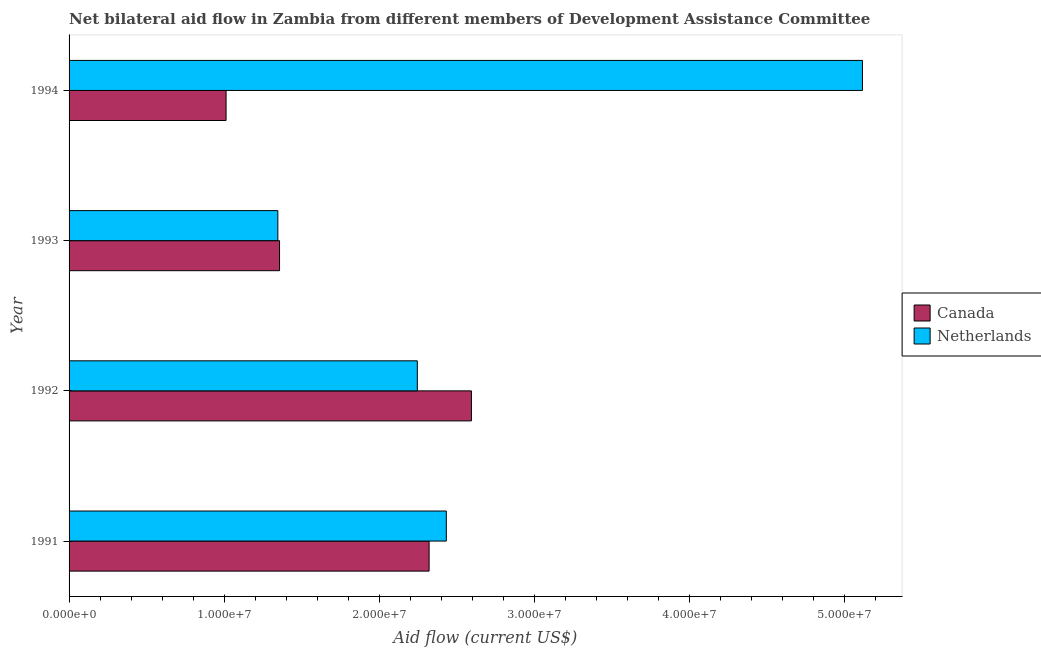How many different coloured bars are there?
Your answer should be very brief. 2. How many groups of bars are there?
Give a very brief answer. 4. How many bars are there on the 4th tick from the top?
Make the answer very short. 2. How many bars are there on the 1st tick from the bottom?
Provide a succinct answer. 2. In how many cases, is the number of bars for a given year not equal to the number of legend labels?
Make the answer very short. 0. What is the amount of aid given by canada in 1993?
Give a very brief answer. 1.36e+07. Across all years, what is the maximum amount of aid given by canada?
Give a very brief answer. 2.60e+07. Across all years, what is the minimum amount of aid given by canada?
Make the answer very short. 1.01e+07. In which year was the amount of aid given by netherlands minimum?
Keep it short and to the point. 1993. What is the total amount of aid given by netherlands in the graph?
Make the answer very short. 1.11e+08. What is the difference between the amount of aid given by netherlands in 1993 and that in 1994?
Provide a short and direct response. -3.77e+07. What is the difference between the amount of aid given by canada in 1994 and the amount of aid given by netherlands in 1991?
Offer a terse response. -1.42e+07. What is the average amount of aid given by netherlands per year?
Provide a succinct answer. 2.79e+07. In the year 1992, what is the difference between the amount of aid given by netherlands and amount of aid given by canada?
Offer a terse response. -3.49e+06. In how many years, is the amount of aid given by canada greater than 8000000 US$?
Your response must be concise. 4. What is the ratio of the amount of aid given by netherlands in 1992 to that in 1994?
Your response must be concise. 0.44. Is the amount of aid given by netherlands in 1992 less than that in 1993?
Offer a very short reply. No. What is the difference between the highest and the second highest amount of aid given by canada?
Your answer should be very brief. 2.73e+06. What is the difference between the highest and the lowest amount of aid given by canada?
Provide a short and direct response. 1.58e+07. What does the 2nd bar from the top in 1992 represents?
Keep it short and to the point. Canada. What does the 1st bar from the bottom in 1993 represents?
Keep it short and to the point. Canada. How many years are there in the graph?
Provide a short and direct response. 4. Are the values on the major ticks of X-axis written in scientific E-notation?
Provide a short and direct response. Yes. Does the graph contain any zero values?
Offer a terse response. No. Does the graph contain grids?
Offer a very short reply. No. Where does the legend appear in the graph?
Your answer should be compact. Center right. How many legend labels are there?
Your response must be concise. 2. How are the legend labels stacked?
Make the answer very short. Vertical. What is the title of the graph?
Ensure brevity in your answer.  Net bilateral aid flow in Zambia from different members of Development Assistance Committee. Does "current US$" appear as one of the legend labels in the graph?
Offer a terse response. No. What is the label or title of the X-axis?
Your response must be concise. Aid flow (current US$). What is the Aid flow (current US$) of Canada in 1991?
Make the answer very short. 2.32e+07. What is the Aid flow (current US$) of Netherlands in 1991?
Your answer should be very brief. 2.43e+07. What is the Aid flow (current US$) of Canada in 1992?
Offer a very short reply. 2.60e+07. What is the Aid flow (current US$) of Netherlands in 1992?
Provide a succinct answer. 2.25e+07. What is the Aid flow (current US$) in Canada in 1993?
Offer a terse response. 1.36e+07. What is the Aid flow (current US$) of Netherlands in 1993?
Your response must be concise. 1.35e+07. What is the Aid flow (current US$) in Canada in 1994?
Offer a terse response. 1.01e+07. What is the Aid flow (current US$) in Netherlands in 1994?
Provide a short and direct response. 5.12e+07. Across all years, what is the maximum Aid flow (current US$) of Canada?
Offer a very short reply. 2.60e+07. Across all years, what is the maximum Aid flow (current US$) in Netherlands?
Offer a very short reply. 5.12e+07. Across all years, what is the minimum Aid flow (current US$) in Canada?
Your response must be concise. 1.01e+07. Across all years, what is the minimum Aid flow (current US$) in Netherlands?
Offer a very short reply. 1.35e+07. What is the total Aid flow (current US$) of Canada in the graph?
Offer a very short reply. 7.29e+07. What is the total Aid flow (current US$) of Netherlands in the graph?
Offer a very short reply. 1.11e+08. What is the difference between the Aid flow (current US$) of Canada in 1991 and that in 1992?
Provide a succinct answer. -2.73e+06. What is the difference between the Aid flow (current US$) of Netherlands in 1991 and that in 1992?
Your answer should be very brief. 1.87e+06. What is the difference between the Aid flow (current US$) of Canada in 1991 and that in 1993?
Provide a short and direct response. 9.65e+06. What is the difference between the Aid flow (current US$) in Netherlands in 1991 and that in 1993?
Offer a very short reply. 1.09e+07. What is the difference between the Aid flow (current US$) in Canada in 1991 and that in 1994?
Keep it short and to the point. 1.31e+07. What is the difference between the Aid flow (current US$) in Netherlands in 1991 and that in 1994?
Your answer should be very brief. -2.68e+07. What is the difference between the Aid flow (current US$) of Canada in 1992 and that in 1993?
Your response must be concise. 1.24e+07. What is the difference between the Aid flow (current US$) of Netherlands in 1992 and that in 1993?
Your response must be concise. 9.00e+06. What is the difference between the Aid flow (current US$) in Canada in 1992 and that in 1994?
Your answer should be compact. 1.58e+07. What is the difference between the Aid flow (current US$) in Netherlands in 1992 and that in 1994?
Provide a short and direct response. -2.87e+07. What is the difference between the Aid flow (current US$) of Canada in 1993 and that in 1994?
Ensure brevity in your answer.  3.45e+06. What is the difference between the Aid flow (current US$) of Netherlands in 1993 and that in 1994?
Make the answer very short. -3.77e+07. What is the difference between the Aid flow (current US$) in Canada in 1991 and the Aid flow (current US$) in Netherlands in 1992?
Offer a very short reply. 7.60e+05. What is the difference between the Aid flow (current US$) in Canada in 1991 and the Aid flow (current US$) in Netherlands in 1993?
Ensure brevity in your answer.  9.76e+06. What is the difference between the Aid flow (current US$) of Canada in 1991 and the Aid flow (current US$) of Netherlands in 1994?
Your response must be concise. -2.80e+07. What is the difference between the Aid flow (current US$) of Canada in 1992 and the Aid flow (current US$) of Netherlands in 1993?
Offer a very short reply. 1.25e+07. What is the difference between the Aid flow (current US$) of Canada in 1992 and the Aid flow (current US$) of Netherlands in 1994?
Give a very brief answer. -2.52e+07. What is the difference between the Aid flow (current US$) in Canada in 1993 and the Aid flow (current US$) in Netherlands in 1994?
Your answer should be very brief. -3.76e+07. What is the average Aid flow (current US$) of Canada per year?
Your response must be concise. 1.82e+07. What is the average Aid flow (current US$) of Netherlands per year?
Offer a terse response. 2.79e+07. In the year 1991, what is the difference between the Aid flow (current US$) in Canada and Aid flow (current US$) in Netherlands?
Your answer should be compact. -1.11e+06. In the year 1992, what is the difference between the Aid flow (current US$) in Canada and Aid flow (current US$) in Netherlands?
Your answer should be very brief. 3.49e+06. In the year 1993, what is the difference between the Aid flow (current US$) in Canada and Aid flow (current US$) in Netherlands?
Offer a terse response. 1.10e+05. In the year 1994, what is the difference between the Aid flow (current US$) of Canada and Aid flow (current US$) of Netherlands?
Your answer should be compact. -4.11e+07. What is the ratio of the Aid flow (current US$) in Canada in 1991 to that in 1992?
Keep it short and to the point. 0.89. What is the ratio of the Aid flow (current US$) of Netherlands in 1991 to that in 1992?
Make the answer very short. 1.08. What is the ratio of the Aid flow (current US$) of Canada in 1991 to that in 1993?
Provide a short and direct response. 1.71. What is the ratio of the Aid flow (current US$) in Netherlands in 1991 to that in 1993?
Offer a terse response. 1.81. What is the ratio of the Aid flow (current US$) of Canada in 1991 to that in 1994?
Provide a succinct answer. 2.29. What is the ratio of the Aid flow (current US$) of Netherlands in 1991 to that in 1994?
Your answer should be very brief. 0.48. What is the ratio of the Aid flow (current US$) of Canada in 1992 to that in 1993?
Provide a succinct answer. 1.91. What is the ratio of the Aid flow (current US$) of Netherlands in 1992 to that in 1993?
Keep it short and to the point. 1.67. What is the ratio of the Aid flow (current US$) of Canada in 1992 to that in 1994?
Make the answer very short. 2.56. What is the ratio of the Aid flow (current US$) in Netherlands in 1992 to that in 1994?
Your response must be concise. 0.44. What is the ratio of the Aid flow (current US$) in Canada in 1993 to that in 1994?
Provide a short and direct response. 1.34. What is the ratio of the Aid flow (current US$) in Netherlands in 1993 to that in 1994?
Your answer should be very brief. 0.26. What is the difference between the highest and the second highest Aid flow (current US$) in Canada?
Provide a short and direct response. 2.73e+06. What is the difference between the highest and the second highest Aid flow (current US$) in Netherlands?
Provide a succinct answer. 2.68e+07. What is the difference between the highest and the lowest Aid flow (current US$) of Canada?
Provide a short and direct response. 1.58e+07. What is the difference between the highest and the lowest Aid flow (current US$) of Netherlands?
Your response must be concise. 3.77e+07. 